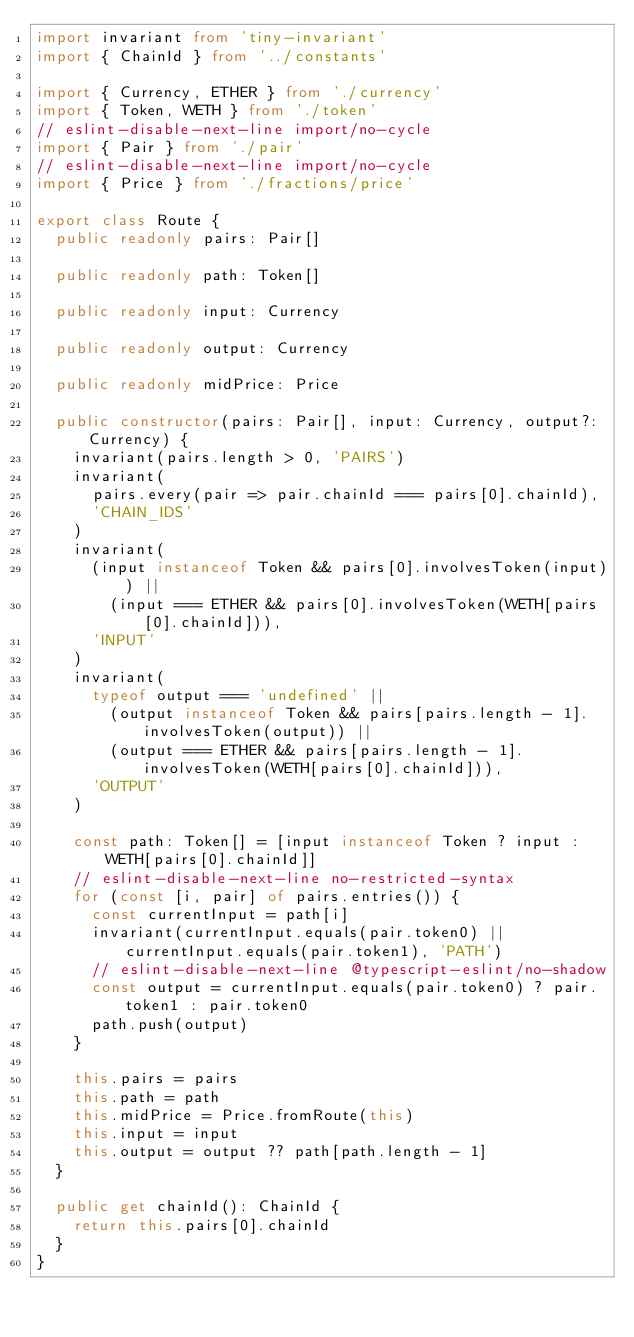<code> <loc_0><loc_0><loc_500><loc_500><_TypeScript_>import invariant from 'tiny-invariant'
import { ChainId } from '../constants'

import { Currency, ETHER } from './currency'
import { Token, WETH } from './token'
// eslint-disable-next-line import/no-cycle
import { Pair } from './pair'
// eslint-disable-next-line import/no-cycle
import { Price } from './fractions/price'

export class Route {
  public readonly pairs: Pair[]

  public readonly path: Token[]

  public readonly input: Currency

  public readonly output: Currency

  public readonly midPrice: Price

  public constructor(pairs: Pair[], input: Currency, output?: Currency) {
    invariant(pairs.length > 0, 'PAIRS')
    invariant(
      pairs.every(pair => pair.chainId === pairs[0].chainId),
      'CHAIN_IDS'
    )
    invariant(
      (input instanceof Token && pairs[0].involvesToken(input)) ||
        (input === ETHER && pairs[0].involvesToken(WETH[pairs[0].chainId])),
      'INPUT'
    )
    invariant(
      typeof output === 'undefined' ||
        (output instanceof Token && pairs[pairs.length - 1].involvesToken(output)) ||
        (output === ETHER && pairs[pairs.length - 1].involvesToken(WETH[pairs[0].chainId])),
      'OUTPUT'
    )

    const path: Token[] = [input instanceof Token ? input : WETH[pairs[0].chainId]]
    // eslint-disable-next-line no-restricted-syntax
    for (const [i, pair] of pairs.entries()) {
      const currentInput = path[i]
      invariant(currentInput.equals(pair.token0) || currentInput.equals(pair.token1), 'PATH')
      // eslint-disable-next-line @typescript-eslint/no-shadow
      const output = currentInput.equals(pair.token0) ? pair.token1 : pair.token0
      path.push(output)
    }

    this.pairs = pairs
    this.path = path
    this.midPrice = Price.fromRoute(this)
    this.input = input
    this.output = output ?? path[path.length - 1]
  }

  public get chainId(): ChainId {
    return this.pairs[0].chainId
  }
}
</code> 